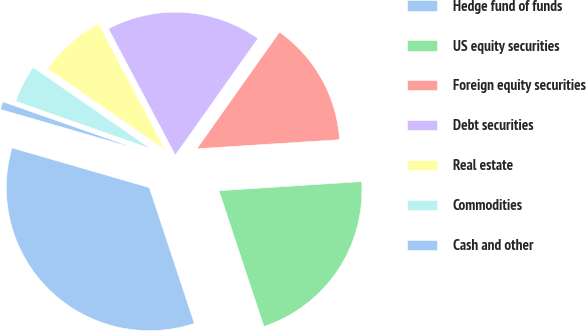Convert chart to OTSL. <chart><loc_0><loc_0><loc_500><loc_500><pie_chart><fcel>Hedge fund of funds<fcel>US equity securities<fcel>Foreign equity securities<fcel>Debt securities<fcel>Real estate<fcel>Commodities<fcel>Cash and other<nl><fcel>34.57%<fcel>20.92%<fcel>14.18%<fcel>17.55%<fcel>7.62%<fcel>4.26%<fcel>0.89%<nl></chart> 